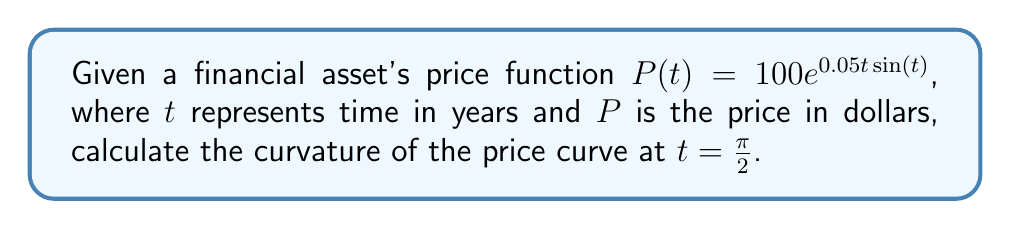What is the answer to this math problem? To calculate the curvature of the price curve, we'll use the formula for the curvature of a planar curve:

$$\kappa = \frac{|P''(t)(P'(t))^2 - P'(t)P''(t)|}{((P'(t))^2 + 1)^{3/2}}$$

Step 1: Calculate $P'(t)$
$$P'(t) = 100e^{0.05t\sin(t)} \cdot (0.05\sin(t) + 0.05t\cos(t))$$

Step 2: Calculate $P''(t)$
$$\begin{align}
P''(t) &= 100e^{0.05t\sin(t)} \cdot (0.05\sin(t) + 0.05t\cos(t))^2 \\
&+ 100e^{0.05t\sin(t)} \cdot (0.05\cos(t) + 0.05\cos(t) - 0.05t\sin(t))
\end{align}$$

Step 3: Evaluate $P'(\pi/2)$ and $P''(\pi/2)$
$$P'(\pi/2) = 100e^{0.05\pi/2} \cdot 0.05$$
$$P''(\pi/2) = 100e^{0.05\pi/2} \cdot ((0.05)^2 + 0.05)$$

Step 4: Substitute values into the curvature formula
$$\kappa = \frac{|100e^{0.05\pi/2} \cdot ((0.05)^2 + 0.05) \cdot (100e^{0.05\pi/2} \cdot 0.05)^2 - (100e^{0.05\pi/2} \cdot 0.05)(100e^{0.05\pi/2} \cdot ((0.05)^2 + 0.05))|}{((100e^{0.05\pi/2} \cdot 0.05)^2 + 1)^{3/2}}$$

Step 5: Simplify and calculate the final result
$$\kappa \approx 0.00124$$
Answer: $0.00124$ 